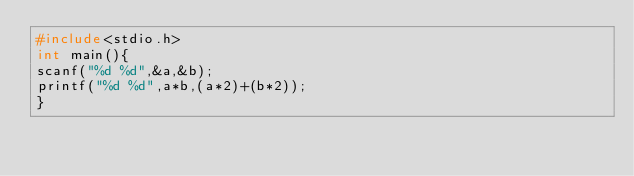Convert code to text. <code><loc_0><loc_0><loc_500><loc_500><_C_>#include<stdio.h>
int main(){
scanf("%d %d",&a,&b);
printf("%d %d",a*b,(a*2)+(b*2));
}</code> 